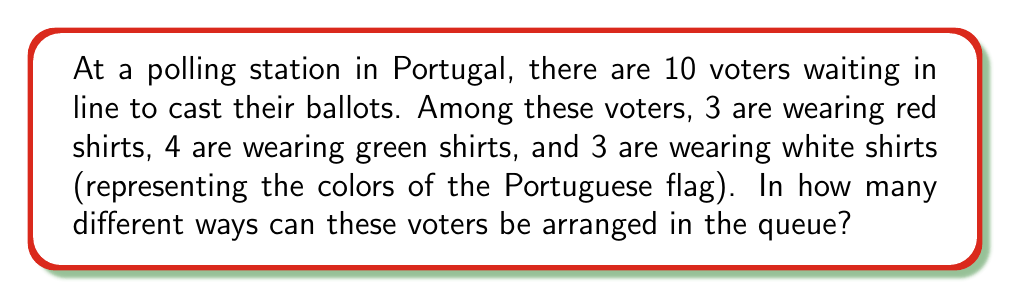Solve this math problem. Let's approach this step-by-step:

1) This is a permutation problem with repeated elements. We need to use the formula for permutations with repetition:

   $$\frac{n!}{n_1! \cdot n_2! \cdot ... \cdot n_k!}$$

   Where:
   $n$ is the total number of items
   $n_1, n_2, ..., n_k$ are the numbers of each type of item

2) In this case:
   $n = 10$ (total number of voters)
   $n_1 = 3$ (red shirts)
   $n_2 = 4$ (green shirts)
   $n_3 = 3$ (white shirts)

3) Plugging these numbers into the formula:

   $$\frac{10!}{3! \cdot 4! \cdot 3!}$$

4) Let's calculate this step-by-step:
   
   $10! = 3,628,800$
   $3! = 6$
   $4! = 24$
   $3! = 6$

5) Now our equation looks like:

   $$\frac{3,628,800}{6 \cdot 24 \cdot 6}$$

6) Simplifying:
   
   $$\frac{3,628,800}{864} = 4,200$$

Therefore, there are 4,200 different ways to arrange these voters in the queue.
Answer: 4,200 